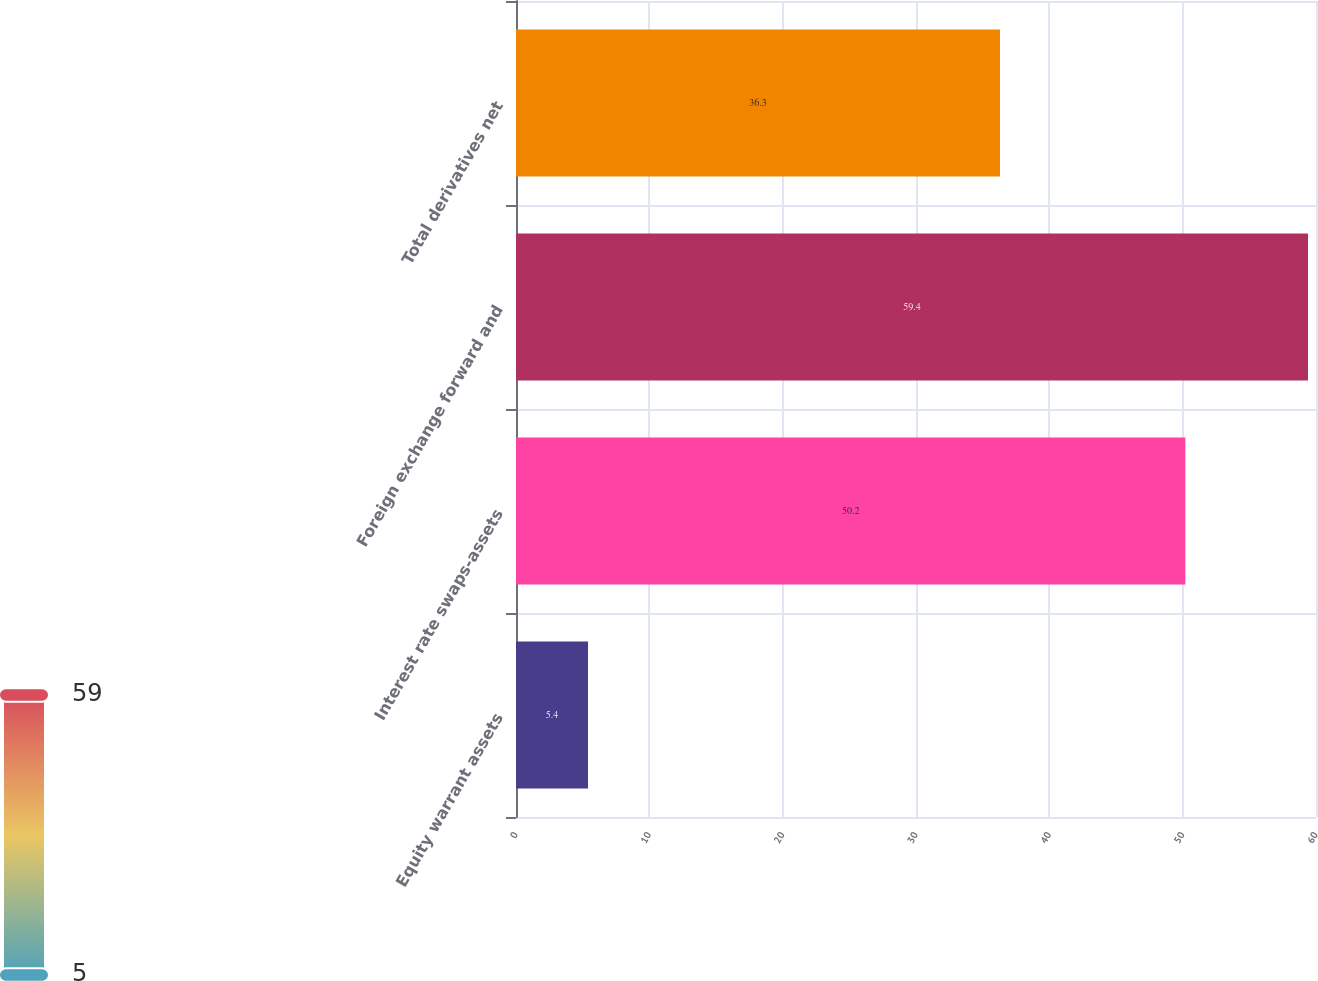Convert chart to OTSL. <chart><loc_0><loc_0><loc_500><loc_500><bar_chart><fcel>Equity warrant assets<fcel>Interest rate swaps-assets<fcel>Foreign exchange forward and<fcel>Total derivatives net<nl><fcel>5.4<fcel>50.2<fcel>59.4<fcel>36.3<nl></chart> 